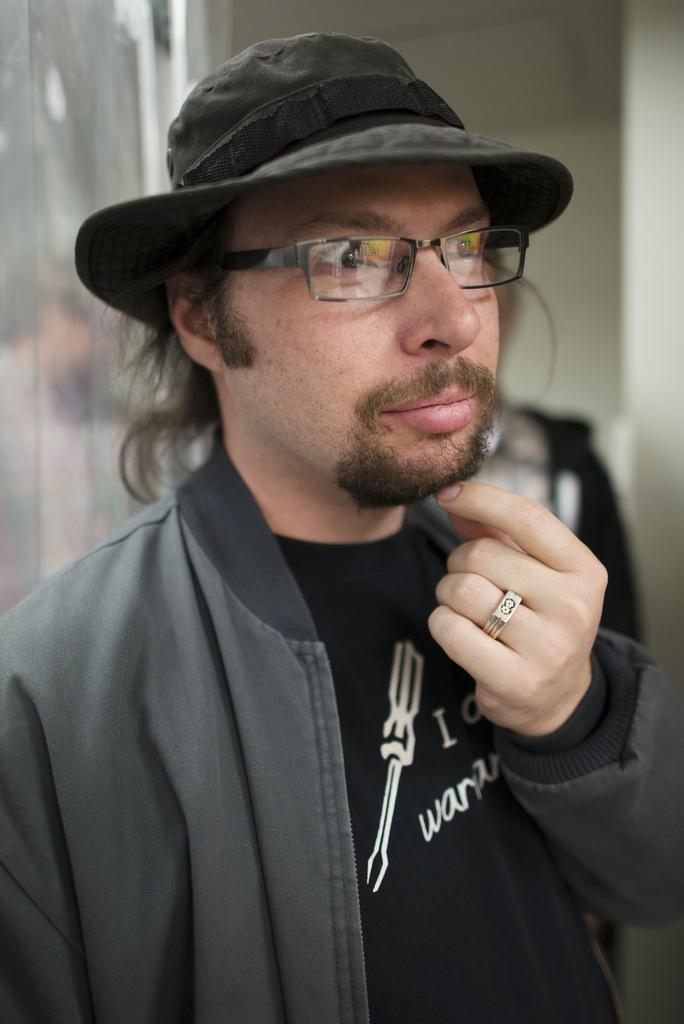Please provide a concise description of this image. In this picture there is a man in the center of the image and there is another man behind him and there is a portrait in the background area of the image. 